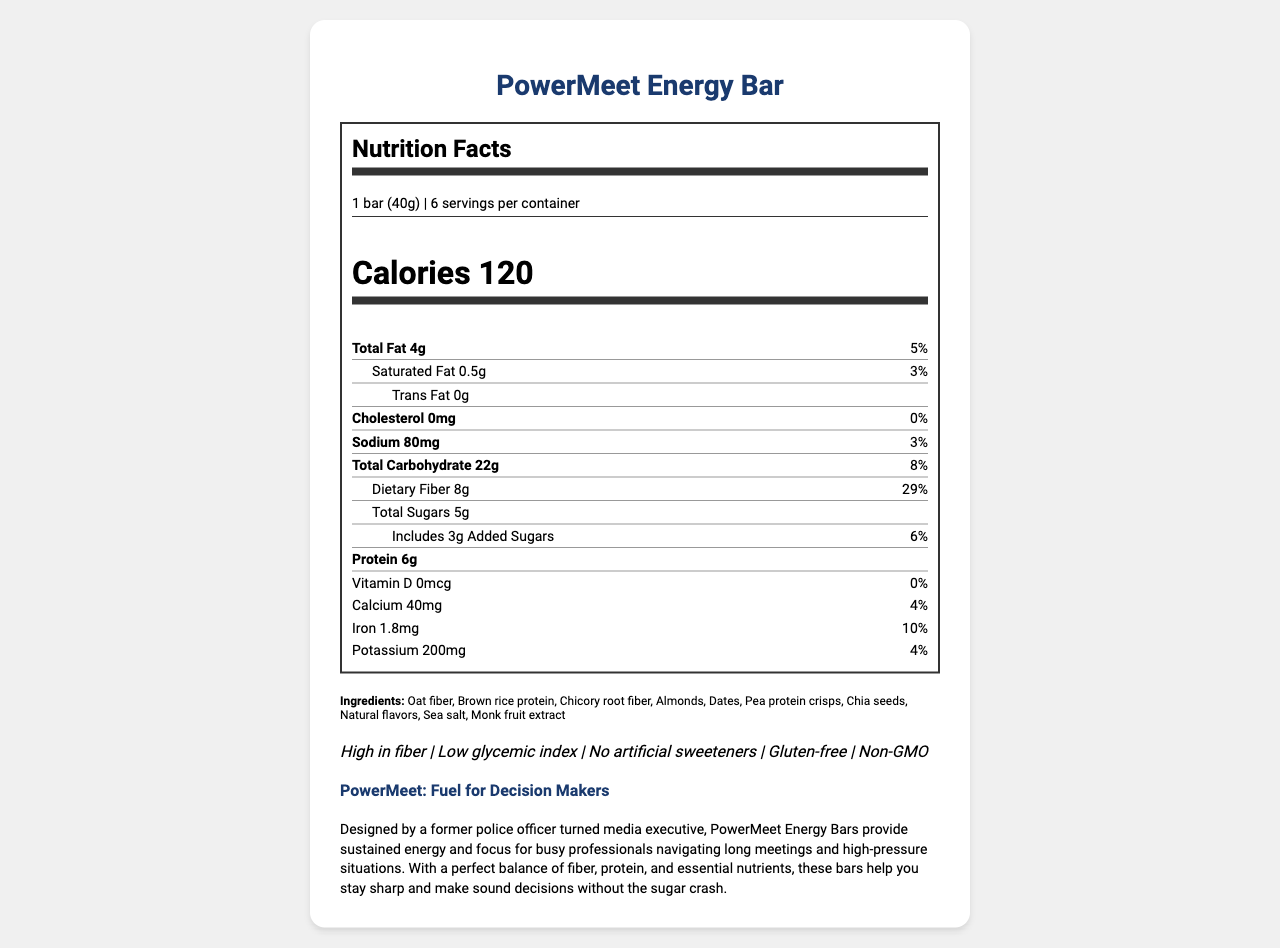What is the serving size for PowerMeet Energy Bar? The serving size is clearly mentioned in the document as "1 bar (40g)".
Answer: 1 bar (40g) How many calories are there per serving of the PowerMeet Energy Bar? The document specifies that there are 120 calories per serving.
Answer: 120 What percentage of the daily value of dietary fiber does one serving provide? The document shows that one serving of the PowerMeet Energy Bar provides 29% of the daily value for dietary fiber.
Answer: 29% How many grams of protein are there in one serving? The document lists the protein content per serving as 6 grams.
Answer: 6g List three main nutrients provided by the PowerMeet Energy Bar. The main nutrients listed in the document include Total Fat, Total Carbohydrate, and Protein.
Answer: Total Fat, Total Carbohydrate, Protein What type of allergen is present in the PowerMeet Energy Bar? The allergen statement in the document specifies that the bar contains almonds.
Answer: Almonds Is the PowerMeet Energy Bar suitable for people with a gluten intolerance? The document includes a claim statement that the bar is gluten-free.
Answer: Yes What is the brand statement for the PowerMeet Energy Bar? The brand statement given in the document is “PowerMeet: Fuel for Decision Makers”.
Answer: PowerMeet: Fuel for Decision Makers Which ingredient is used as a sweetener in the PowerMeet Energy Bar? The list of ingredients includes monk fruit extract as a natural sweetener.
Answer: Monk fruit extract What is the sodium content per serving, and what percentage of the daily value does it represent? The sodium content per serving is 80mg, which represents 3% of the daily value.
Answer: 80mg, 3% Which of these nutrients is not present in the PowerMeet Energy Bar? A. Vitamin D B. Calcium C. Protein The document indicates that Vitamin D content is 0mcg, implying it is not present in the PowerMeet Energy Bar.
Answer: A. Vitamin D What type of product is the PowerMeet Energy Bar labeled as? A. High in protein B. Low-calorie C. High in fiber The claim statements include “High in fiber,” while the other options are not specifically mentioned.
Answer: C. High in fiber Does the PowerMeet Energy Bar contain any artificial sweeteners? The claim statements in the document indicate that the bar contains no artificial sweeteners.
Answer: No Summarize the main idea of the PowerMeet Energy Bar document. The document includes nutritional information, ingredients, allergen statement, claim statements, brand statement, and product description highlighting the benefits and suitability of the energy bar for busy executives.
Answer: The PowerMeet Energy Bar is a low-calorie, high-fiber snack designed for busy professionals attending long meetings. It provides sustained energy, high fiber, protein, and essential nutrients without sugar crashes, and is free from artificial sweeteners, gluten, and GMOs. What is the manufacturing facility's potential cross-contamination risk? The document only states that the facility processes peanuts, tree nuts, soy, and milk but does not provide detailed risk assessment information.
Answer: Not enough information How many servings are there per container of the PowerMeet Energy Bar? The document specifies that there are 6 servings per container.
Answer: 6 